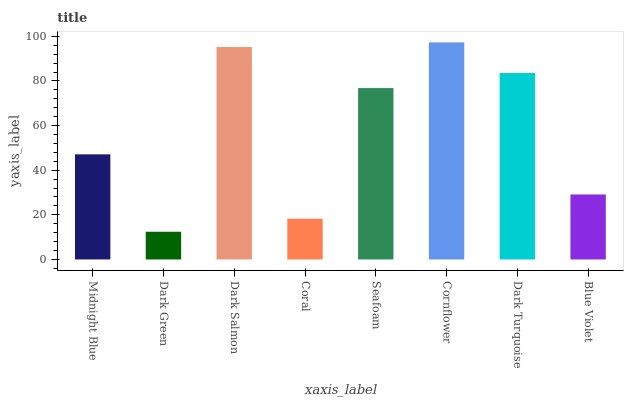Is Dark Green the minimum?
Answer yes or no. Yes. Is Cornflower the maximum?
Answer yes or no. Yes. Is Dark Salmon the minimum?
Answer yes or no. No. Is Dark Salmon the maximum?
Answer yes or no. No. Is Dark Salmon greater than Dark Green?
Answer yes or no. Yes. Is Dark Green less than Dark Salmon?
Answer yes or no. Yes. Is Dark Green greater than Dark Salmon?
Answer yes or no. No. Is Dark Salmon less than Dark Green?
Answer yes or no. No. Is Seafoam the high median?
Answer yes or no. Yes. Is Midnight Blue the low median?
Answer yes or no. Yes. Is Cornflower the high median?
Answer yes or no. No. Is Coral the low median?
Answer yes or no. No. 